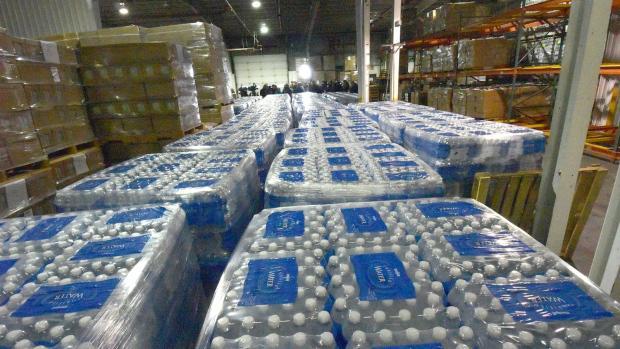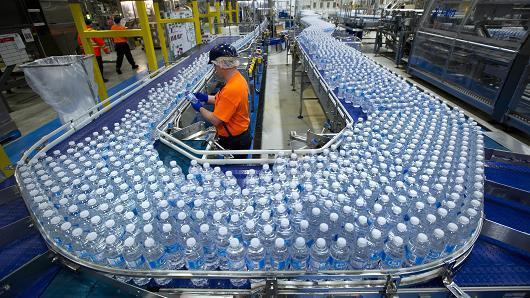The first image is the image on the left, the second image is the image on the right. Given the left and right images, does the statement "A person in an orange shirt stands near a belt of bottles." hold true? Answer yes or no. Yes. 